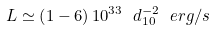<formula> <loc_0><loc_0><loc_500><loc_500>L \simeq \left ( 1 - 6 \right ) 1 0 ^ { 3 3 } \ d _ { 1 0 } ^ { - 2 } \ e r g / s</formula> 